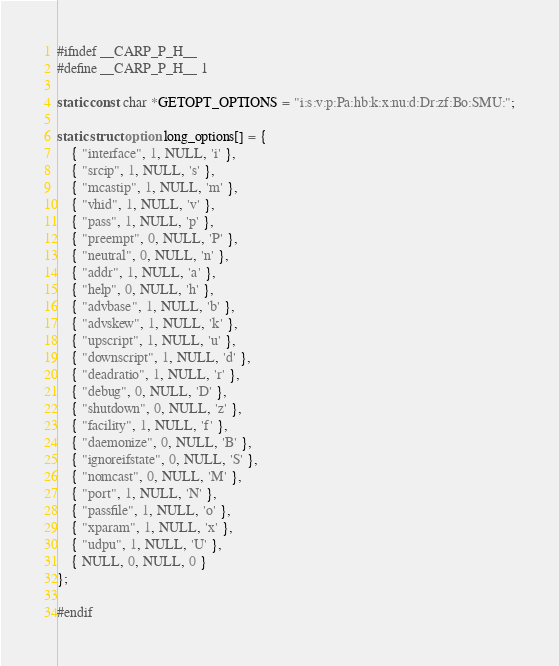<code> <loc_0><loc_0><loc_500><loc_500><_C_>#ifndef __CARP_P_H__
#define __CARP_P_H__ 1

static const char *GETOPT_OPTIONS = "i:s:v:p:Pa:hb:k:x:nu:d:Dr:zf:Bo:SMU:";

static struct option long_options[] = {
    { "interface", 1, NULL, 'i' },
    { "srcip", 1, NULL, 's' },
    { "mcastip", 1, NULL, 'm' },
    { "vhid", 1, NULL, 'v' },
    { "pass", 1, NULL, 'p' },
    { "preempt", 0, NULL, 'P' },
    { "neutral", 0, NULL, 'n' },
    { "addr", 1, NULL, 'a' },
    { "help", 0, NULL, 'h' },
    { "advbase", 1, NULL, 'b' },
    { "advskew", 1, NULL, 'k' },
    { "upscript", 1, NULL, 'u' },
    { "downscript", 1, NULL, 'd' },
    { "deadratio", 1, NULL, 'r' },
    { "debug", 0, NULL, 'D' },
    { "shutdown", 0, NULL, 'z' },
    { "facility", 1, NULL, 'f' },
    { "daemonize", 0, NULL, 'B' },
    { "ignoreifstate", 0, NULL, 'S' },
    { "nomcast", 0, NULL, 'M' },
    { "port", 1, NULL, 'N' },
    { "passfile", 1, NULL, 'o' },
    { "xparam", 1, NULL, 'x' },
	{ "udpu", 1, NULL, 'U' },
    { NULL, 0, NULL, 0 }
};

#endif
</code> 